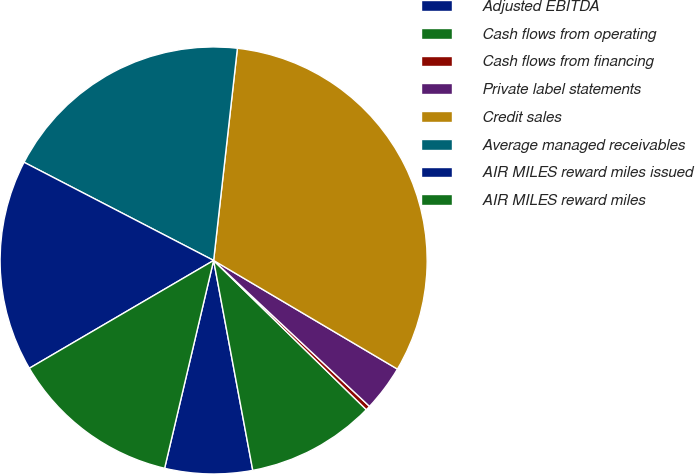Convert chart to OTSL. <chart><loc_0><loc_0><loc_500><loc_500><pie_chart><fcel>Adjusted EBITDA<fcel>Cash flows from operating<fcel>Cash flows from financing<fcel>Private label statements<fcel>Credit sales<fcel>Average managed receivables<fcel>AIR MILES reward miles issued<fcel>AIR MILES reward miles<nl><fcel>6.62%<fcel>9.75%<fcel>0.34%<fcel>3.48%<fcel>31.72%<fcel>19.17%<fcel>16.03%<fcel>12.89%<nl></chart> 